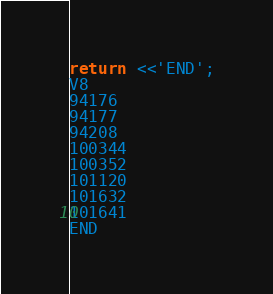Convert code to text. <code><loc_0><loc_0><loc_500><loc_500><_Perl_>
return <<'END';
V8
94176
94177
94208
100344
100352
101120
101632
101641
END
</code> 